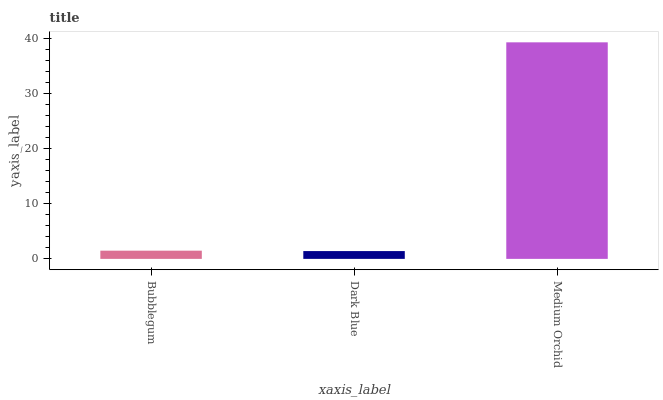Is Dark Blue the minimum?
Answer yes or no. Yes. Is Medium Orchid the maximum?
Answer yes or no. Yes. Is Medium Orchid the minimum?
Answer yes or no. No. Is Dark Blue the maximum?
Answer yes or no. No. Is Medium Orchid greater than Dark Blue?
Answer yes or no. Yes. Is Dark Blue less than Medium Orchid?
Answer yes or no. Yes. Is Dark Blue greater than Medium Orchid?
Answer yes or no. No. Is Medium Orchid less than Dark Blue?
Answer yes or no. No. Is Bubblegum the high median?
Answer yes or no. Yes. Is Bubblegum the low median?
Answer yes or no. Yes. Is Medium Orchid the high median?
Answer yes or no. No. Is Medium Orchid the low median?
Answer yes or no. No. 